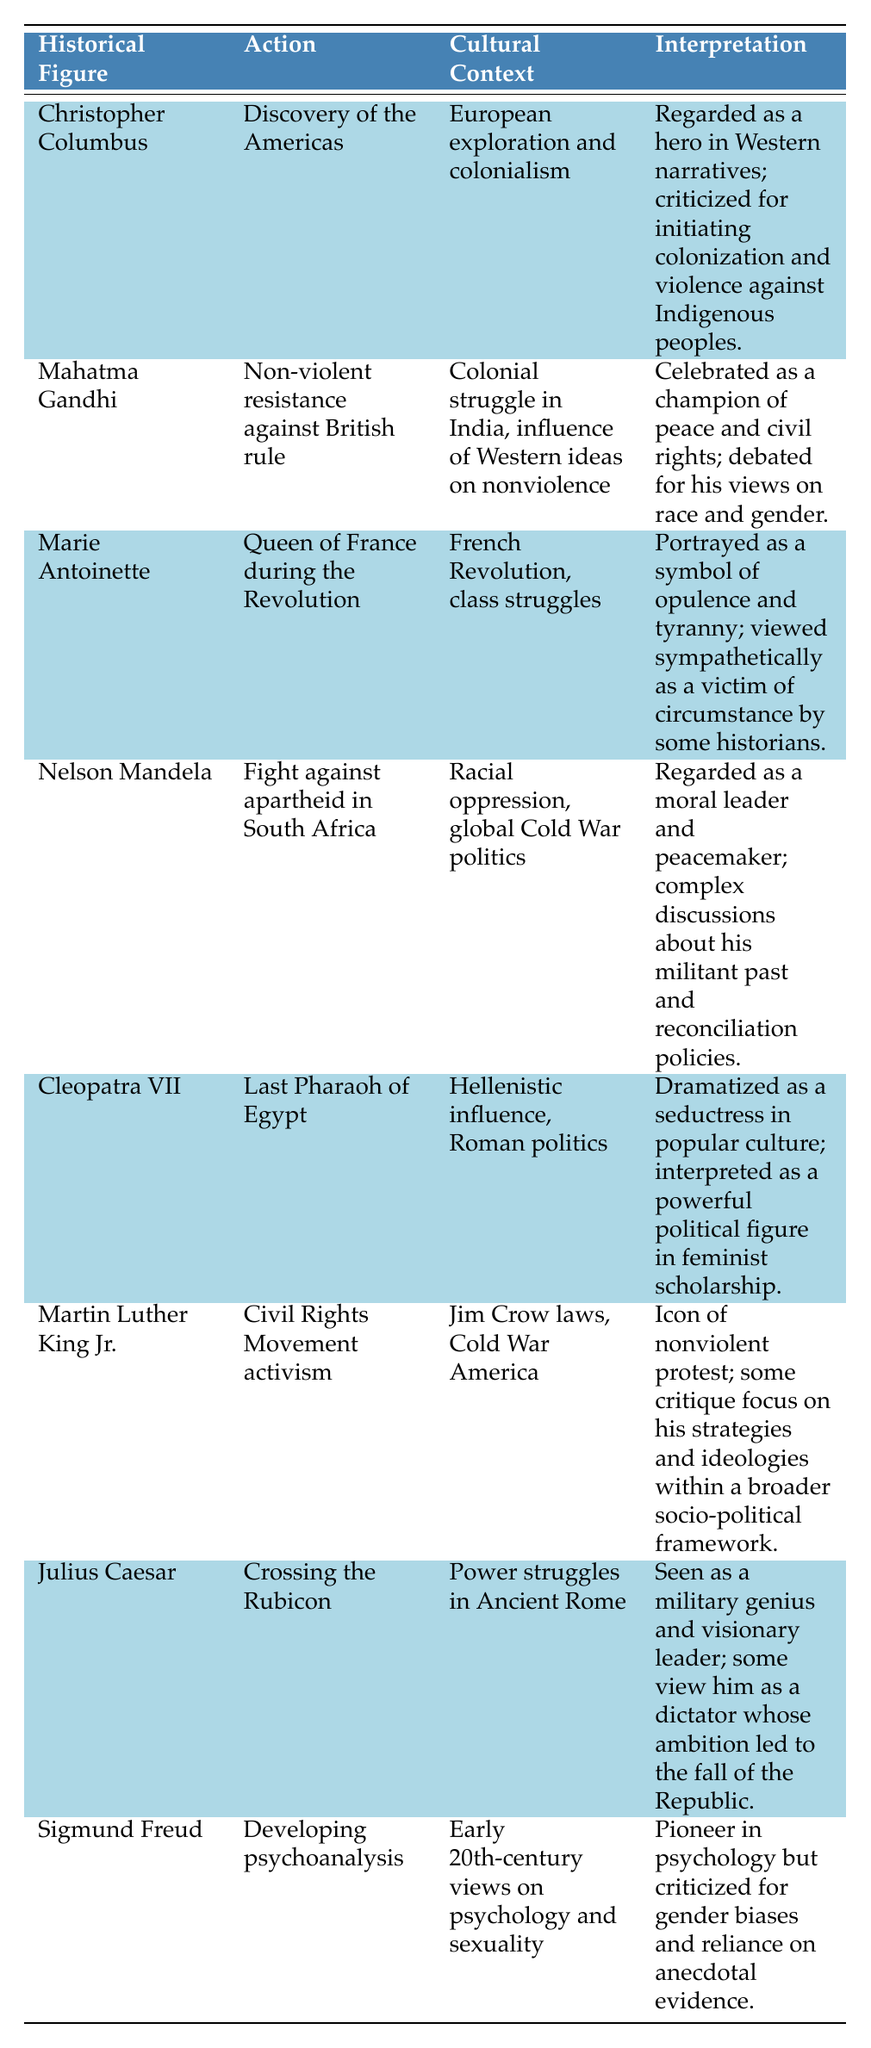What is the cultural context of Mahatma Gandhi's actions? The table indicates that Gandhi's action, "Non-violent resistance against British rule," takes place within the cultural context of "Colonial struggle in India, influence of Western ideas on nonviolence." Therefore, the cultural context is related to India's fight against colonialism and the influence of nonviolent philosophy.
Answer: Colonial struggle in India, influence of Western ideas on nonviolence Which historical figure is regarded as a hero in Western narratives according to the table? The table specifies that Christopher Columbus is "Regarded as a hero in Western narratives" for his action of "Discovery of the Americas." This directly shows the perception surrounding Columbus in cultural contexts.
Answer: Christopher Columbus Is there a historical figure on the table who was both criticized and celebrated? Yes, the table shows that Mahatma Gandhi is celebrated as a champion of peace and civil rights, while there is debate about his views on race and gender, indicating both criticism and admiration. Therefore, he fits this description.
Answer: Yes What is the interpretation of Marie Antoinette’s actions as per the table? The table states that Marie Antoinette is "Portrayed as a symbol of opulence and tyranny; viewed sympathetically as a victim of circumstance by some historians." This dual interpretation reflects differing perspectives on her role during the French Revolution.
Answer: Portrayed as a symbol of opulence and tyranny; viewed sympathetically as a victim of circumstance Compare the interpretations of Nelson Mandela and Julius Caesar based on their actions. Nelson Mandela is regarded as a moral leader and peacemaker, with complex discussions about his past, while Julius Caesar is seen as both a military genius and a dictator whose ambition led to the Republic's fall. Both interpretations reflect contrasting views shaped by their respective cultural contexts, but both involve some level of complexity in their legacies.
Answer: Mandela is seen as a moral leader; Caesar as a military genius or dictator 